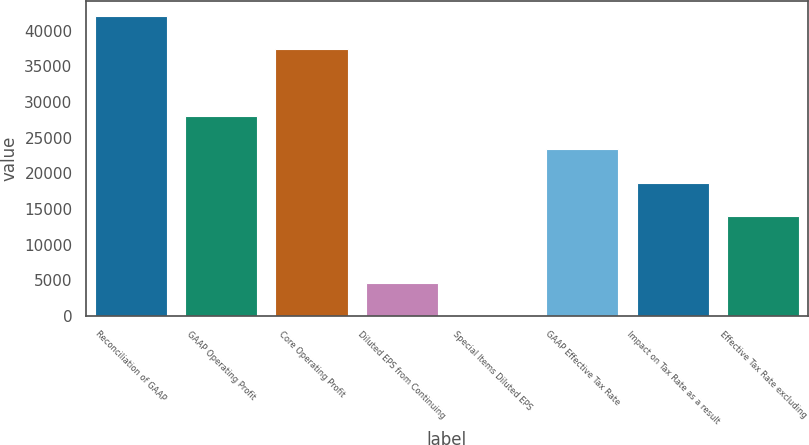Convert chart. <chart><loc_0><loc_0><loc_500><loc_500><bar_chart><fcel>Reconciliation of GAAP<fcel>GAAP Operating Profit<fcel>Core Operating Profit<fcel>Diluted EPS from Continuing<fcel>Special Items Diluted EPS<fcel>GAAP Effective Tax Rate<fcel>Impact on Tax Rate as a result<fcel>Effective Tax Rate excluding<nl><fcel>42105.7<fcel>28070.7<fcel>37427.4<fcel>4679.13<fcel>0.81<fcel>23392.4<fcel>18714.1<fcel>14035.8<nl></chart> 